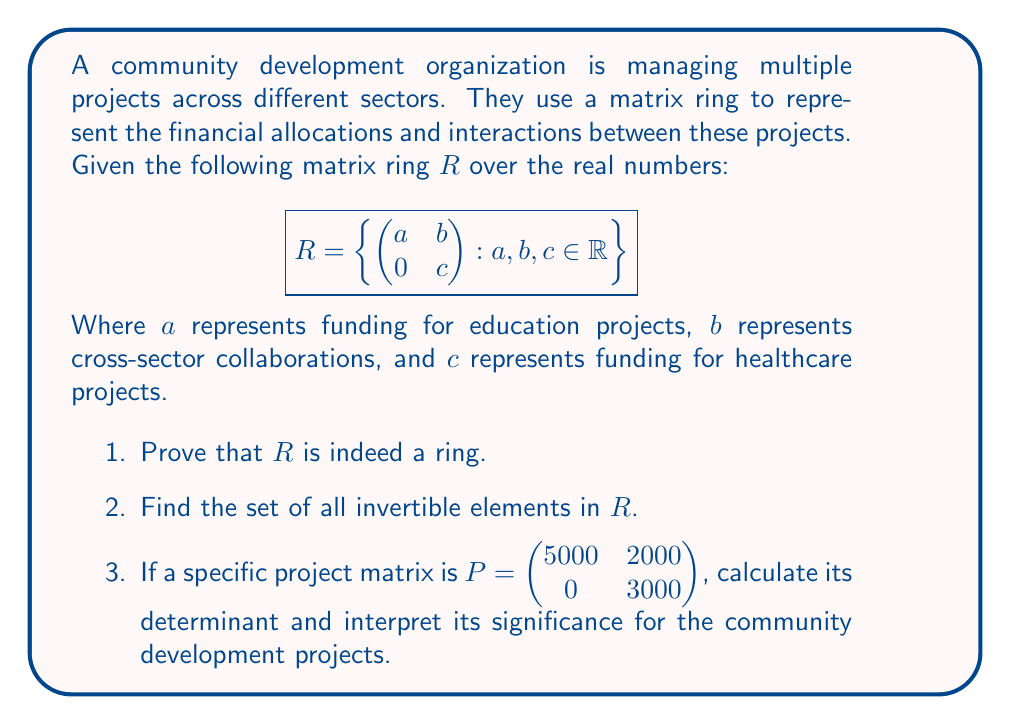Can you solve this math problem? 1. To prove $R$ is a ring, we need to show it's closed under addition and multiplication, has additive and multiplicative identities, and satisfies other ring axioms.

   a) Closure under addition:
      $$\begin{pmatrix}a_1 & b_1 \\ 0 & c_1\end{pmatrix} + \begin{pmatrix}a_2 & b_2 \\ 0 & c_2\end{pmatrix} = \begin{pmatrix}a_1+a_2 & b_1+b_2 \\ 0 & c_1+c_2\end{pmatrix}$$
      This is in $R$, so closure under addition holds.

   b) Closure under multiplication:
      $$\begin{pmatrix}a_1 & b_1 \\ 0 & c_1\end{pmatrix} \cdot \begin{pmatrix}a_2 & b_2 \\ 0 & c_2\end{pmatrix} = \begin{pmatrix}a_1a_2 & a_1b_2+b_1c_2 \\ 0 & c_1c_2\end{pmatrix}$$
      This is in $R$, so closure under multiplication holds.

   c) Additive identity: $\begin{pmatrix}0 & 0 \\ 0 & 0\end{pmatrix}$
   
   d) Multiplicative identity: $\begin{pmatrix}1 & 0 \\ 0 & 1\end{pmatrix}$

   Other ring axioms (associativity, distributivity) follow from matrix algebra. Thus, $R$ is a ring.

2. For a matrix in $R$ to be invertible, its determinant must be non-zero. The determinant is $ac$.
   So, the set of invertible elements is:
   $$\left\{\begin{pmatrix}a & b \\ 0 & c\end{pmatrix} : a, c \neq 0, b \in \mathbb{R}\right\}$$

3. For $P = \begin{pmatrix}5000 & 2000 \\ 0 & 3000\end{pmatrix}$:
   
   Determinant = $5000 \cdot 3000 - 0 \cdot 2000 = 15,000,000$

   Interpretation: The determinant represents the overall impact of the projects. A positive determinant indicates that the education and healthcare projects are both receiving positive funding. The magnitude (15 million) suggests a significant overall investment in these community development projects. The non-zero determinant also means this project matrix is invertible, indicating that the funding allocation is reversible or adjustable if needed.
Answer: 1. $R$ is a ring
2. $\left\{\begin{pmatrix}a & b \\ 0 & c\end{pmatrix} : a, c \neq 0, b \in \mathbb{R}\right\}$
3. 15,000,000; indicates significant, positive, and adjustable investment in education and healthcare projects 